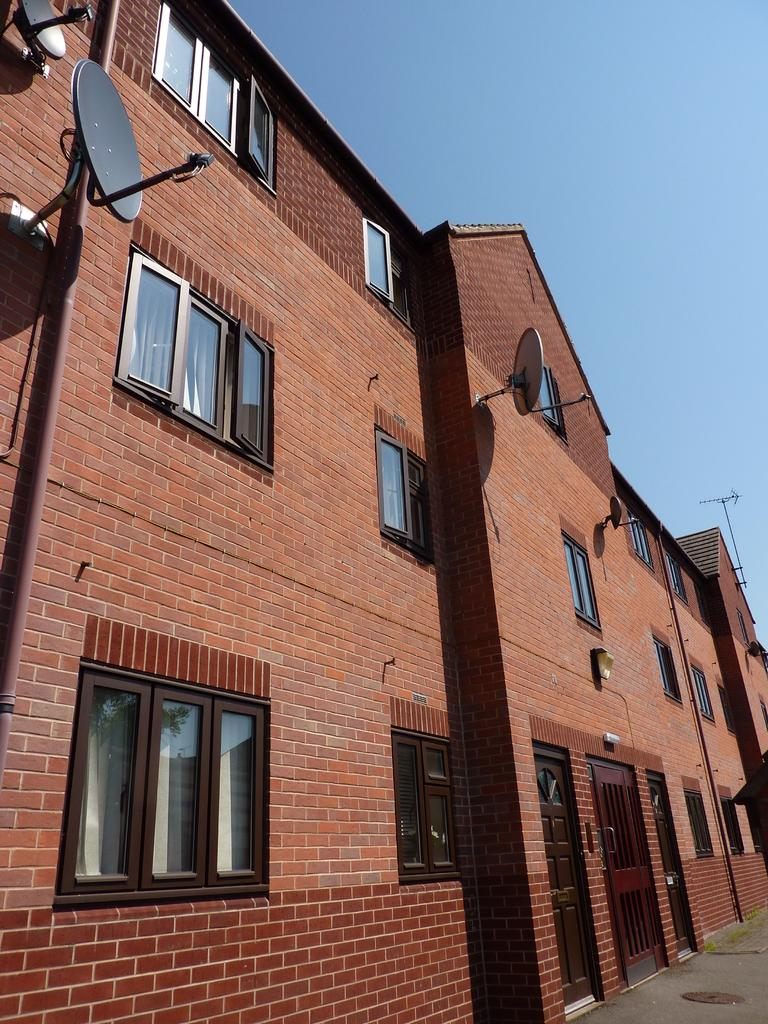What type of structure is present in the image? There is a building in the image. What can be seen on the building? There are dish antennas on the building. Are there any openings on the building? Yes, there are windows on the building. What is visible at the top of the image? The sky is visible at the top of the image. What time is it in the image? The time cannot be determined from the image, as there is no clock or any indication of the time of day. 